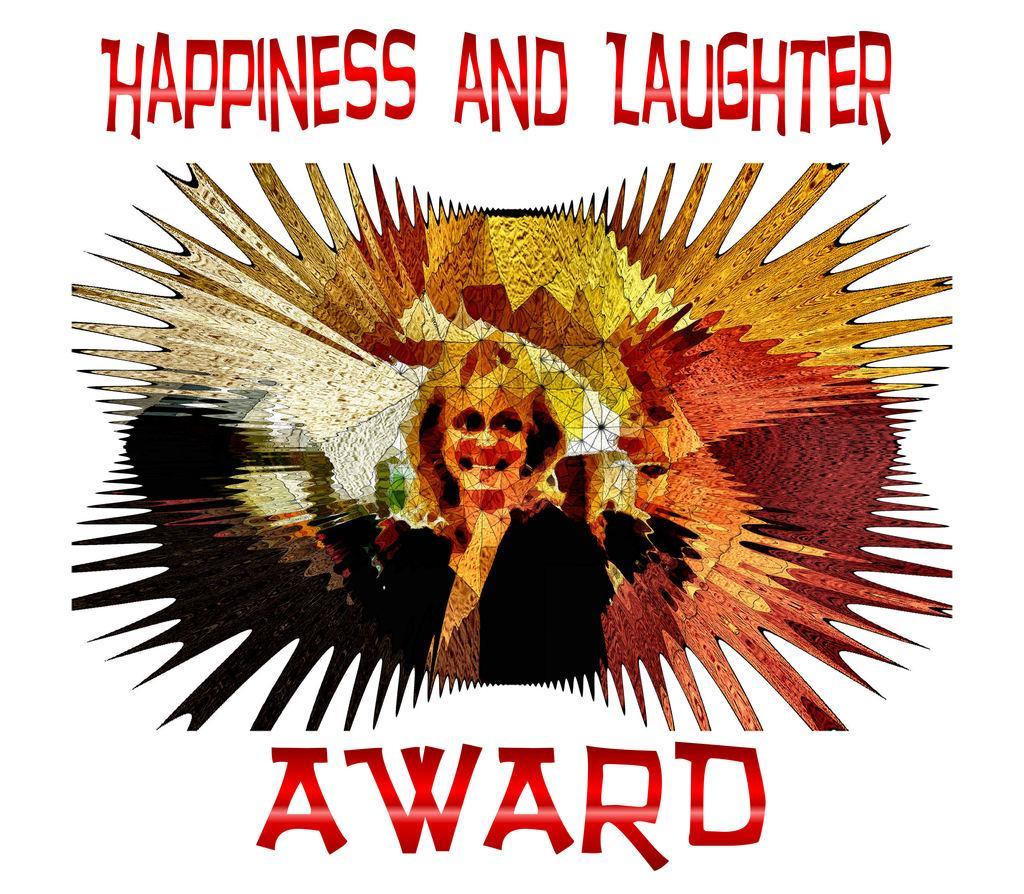Please provide a concise description of this image. This is a graphic image with a picture of a person and some text. 